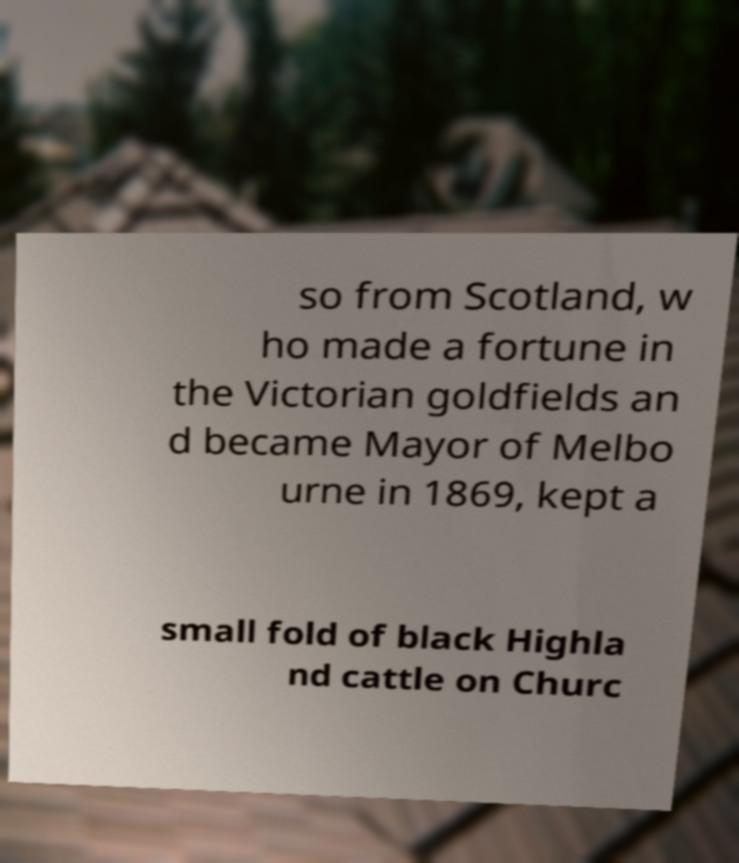Please read and relay the text visible in this image. What does it say? so from Scotland, w ho made a fortune in the Victorian goldfields an d became Mayor of Melbo urne in 1869, kept a small fold of black Highla nd cattle on Churc 